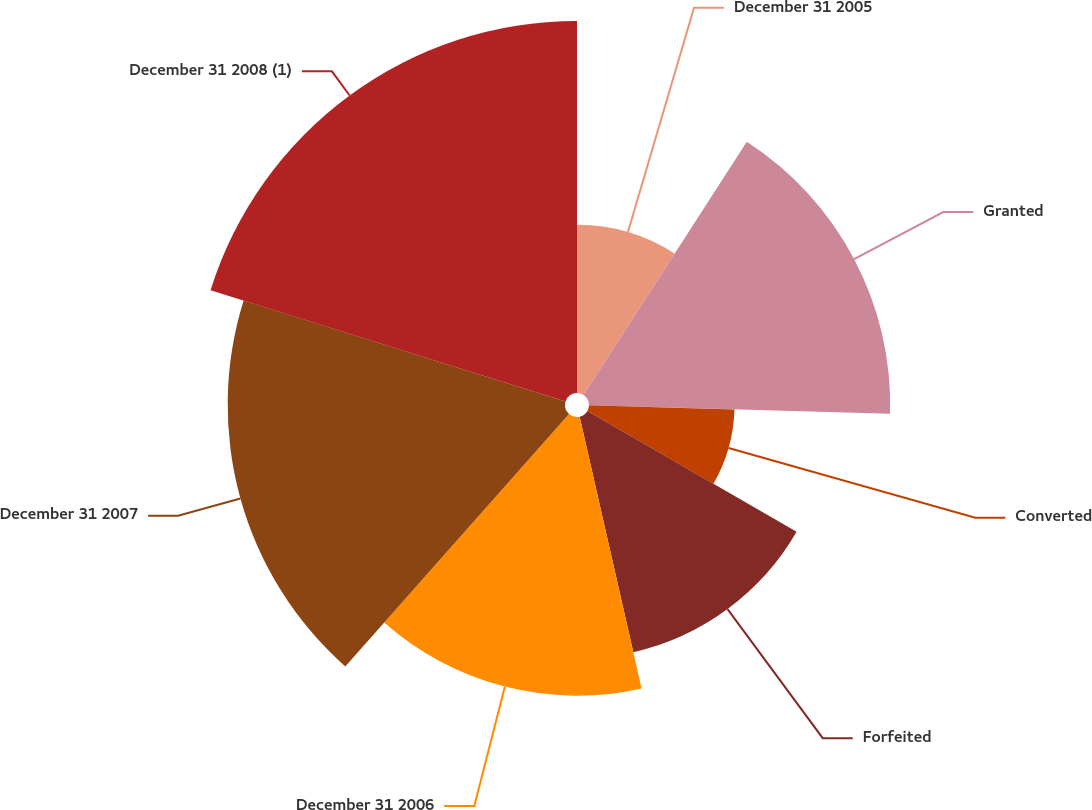<chart> <loc_0><loc_0><loc_500><loc_500><pie_chart><fcel>December 31 2005<fcel>Granted<fcel>Converted<fcel>Forfeited<fcel>December 31 2006<fcel>December 31 2007<fcel>December 31 2008 (1)<nl><fcel>9.12%<fcel>16.33%<fcel>7.89%<fcel>13.1%<fcel>15.11%<fcel>18.29%<fcel>20.17%<nl></chart> 